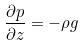Convert formula to latex. <formula><loc_0><loc_0><loc_500><loc_500>\frac { \partial p } { \partial z } = - \rho g</formula> 